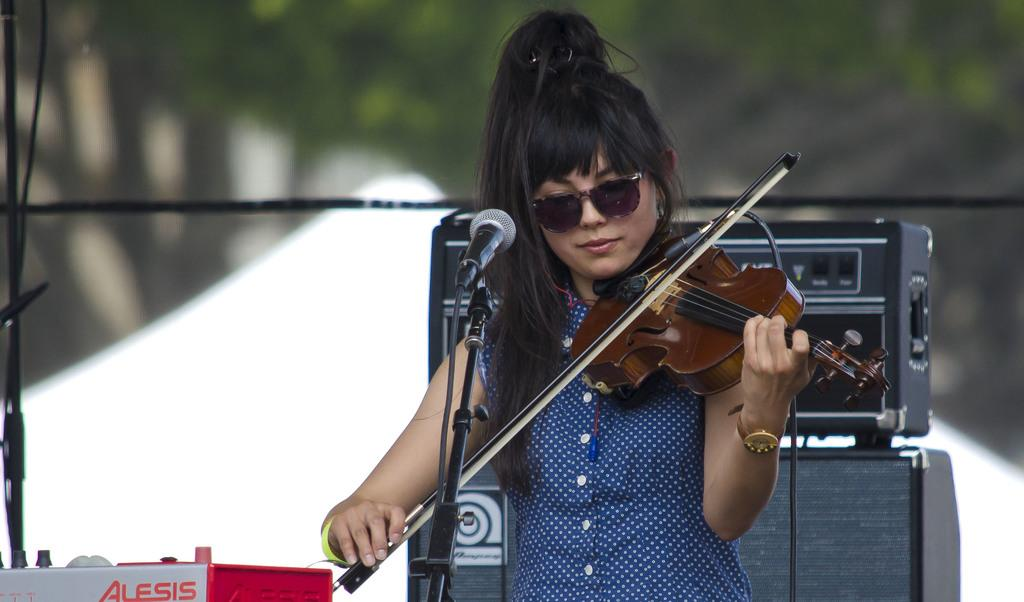What instrument is the woman playing in the image? The woman is playing a violin in the image. How is the woman's performance being amplified? The woman is using a microphone in the image. What protective eyewear is the woman wearing? The woman is wearing goggles in the image. What equipment is present to support the performance? There is a music system and a speaker in the image. What type of wood can be seen in the wilderness behind the woman? There is no wood or wilderness visible in the image; it features a woman playing a violin with a microphone, goggles, and a music system. 